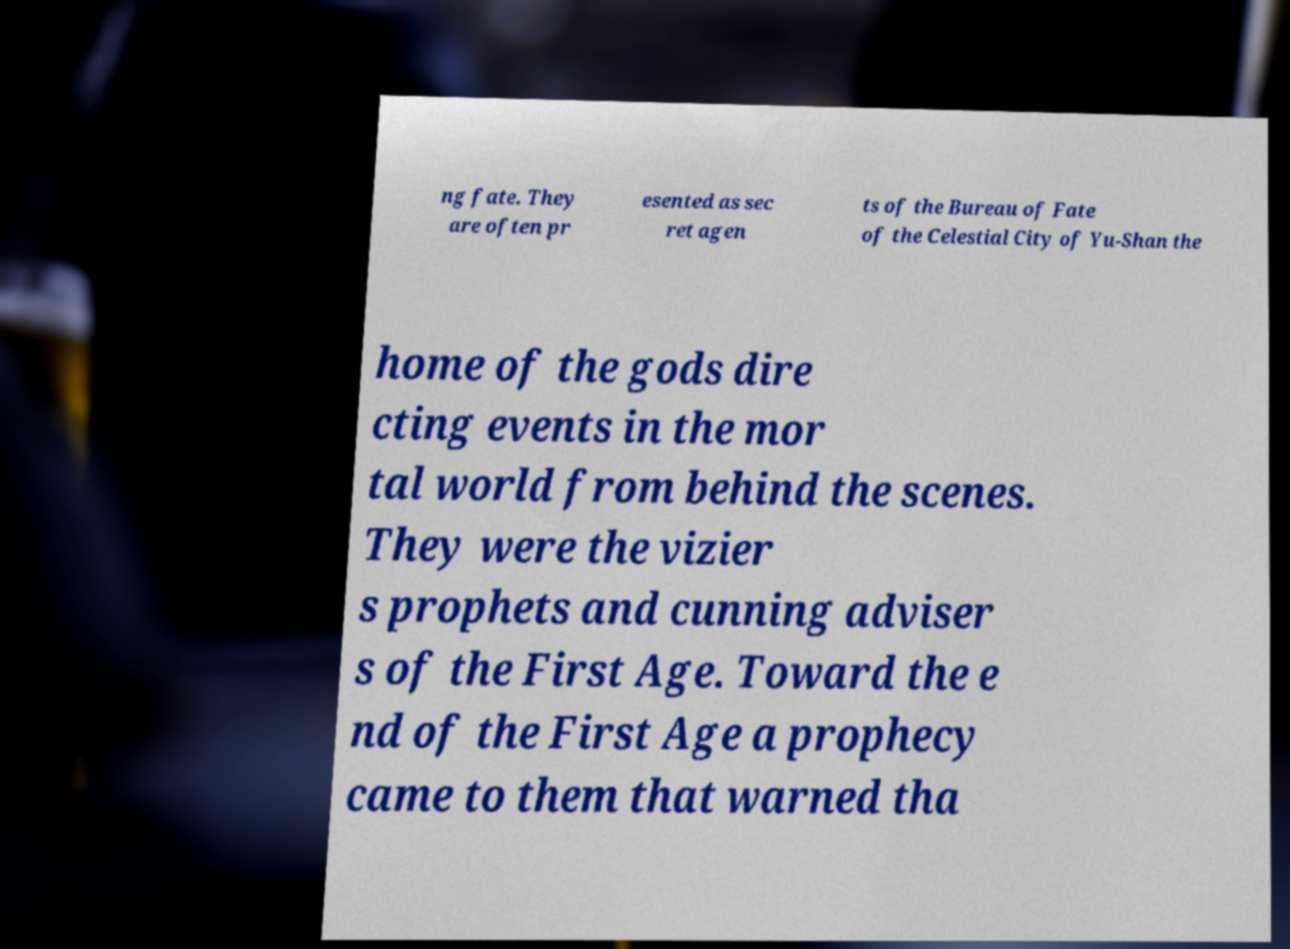I need the written content from this picture converted into text. Can you do that? ng fate. They are often pr esented as sec ret agen ts of the Bureau of Fate of the Celestial City of Yu-Shan the home of the gods dire cting events in the mor tal world from behind the scenes. They were the vizier s prophets and cunning adviser s of the First Age. Toward the e nd of the First Age a prophecy came to them that warned tha 